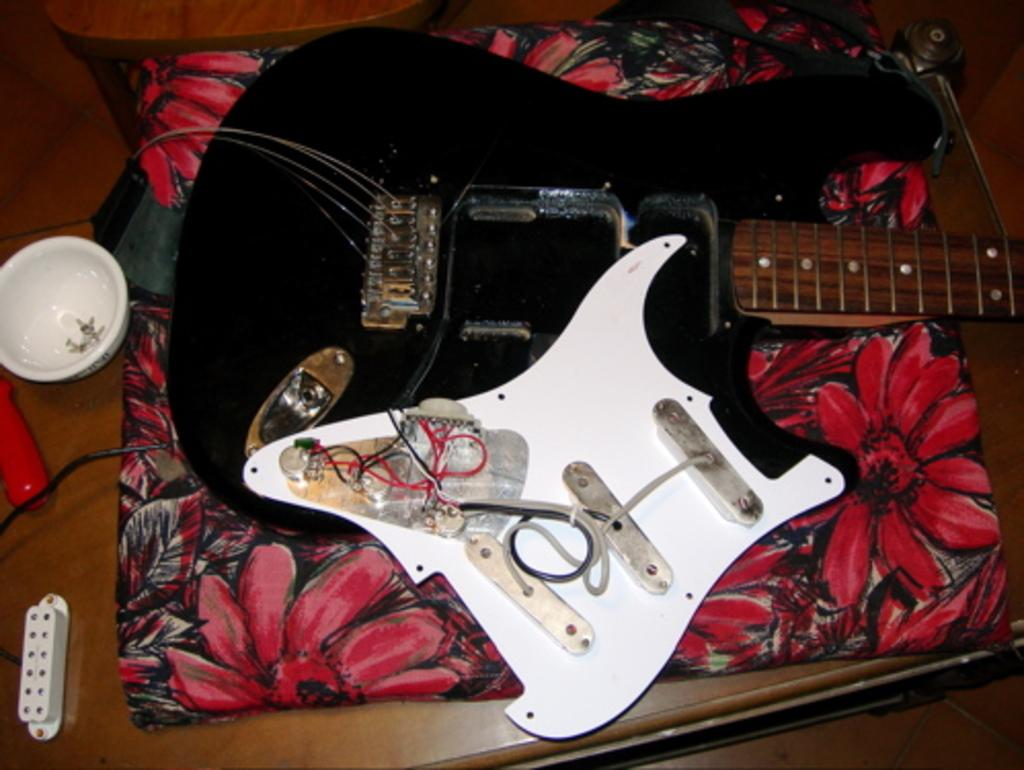What is on the floor in the image? There is luggage and a guitar on the floor in the image. What else can be seen in the image besides the items on the floor? There is a bowl visible in the image. Is there any furniture in the image? Yes, there is a chair in the image. What type of pot is the woman using to make a suggestion in the image? There is no woman or pot present in the image, and no suggestion is being made. 